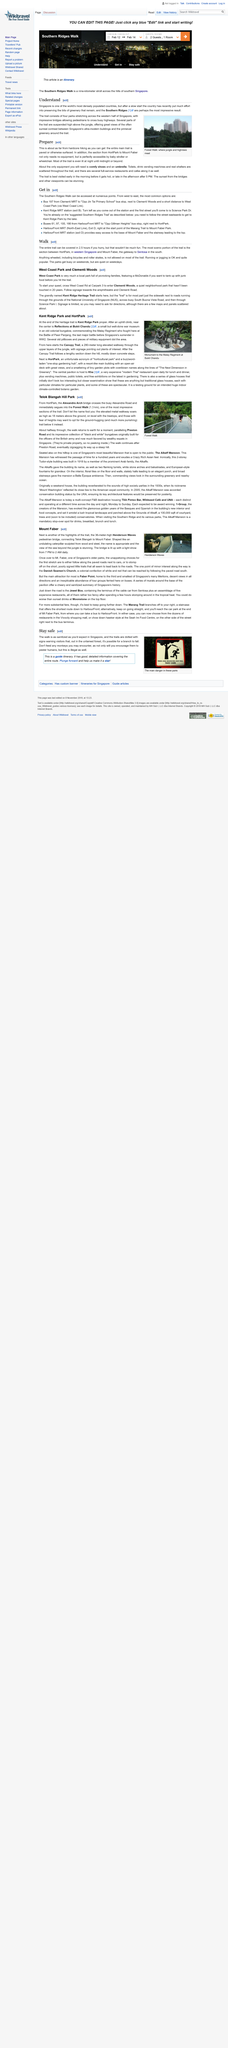Give some essential details in this illustration. The image depicts the Henderson Waves, which is a popular hiking trail found in the mountainous region of Singapore. The Forest Walk is a 1.3 kilometer long endeavor. It is illegal to feed the monkeys as per the authorities' directive. In the article, "Forest Walk" is used as an example to illustrate a concept. The picture accompanying the article depicts a scene of Forest Walk. It is necessary to wear comfortable shoes and bring an umbrella while hiking on the trails in Southern Ridges. 